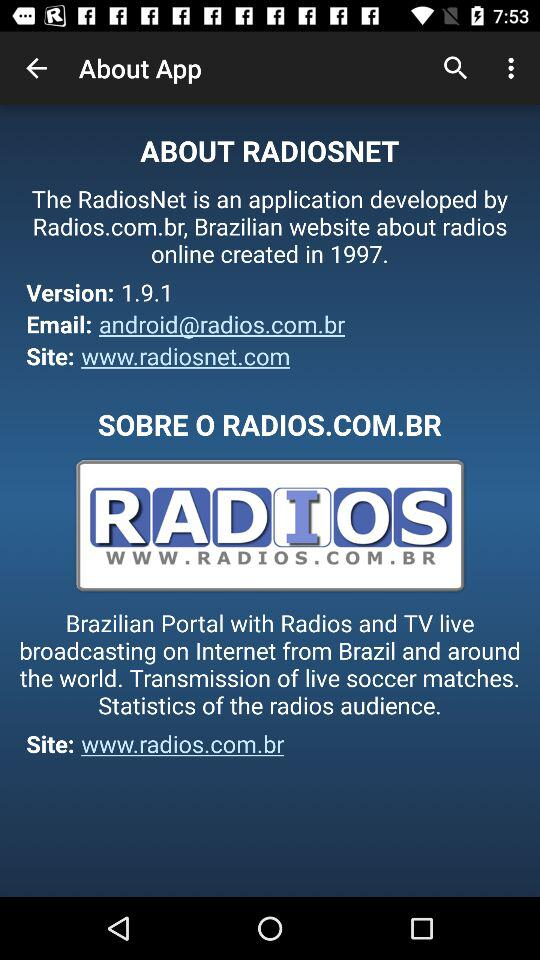What is the website link? The website links are www.radiosnet.com and www.radios.com.br. 